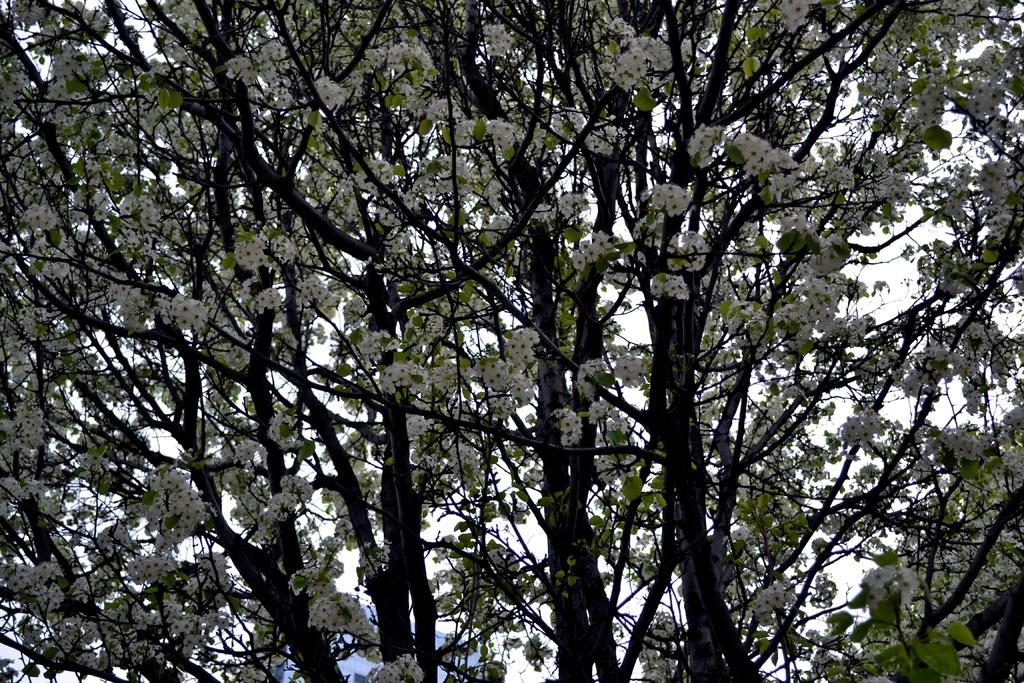What type of vegetation is present in the image? There are trees with flowers in the image. What can be seen in the background of the image? The sky is visible in the background of the image. How many feet does the government have in the image? There is no mention of a government or feet in the image; it features trees with flowers and a visible sky. 